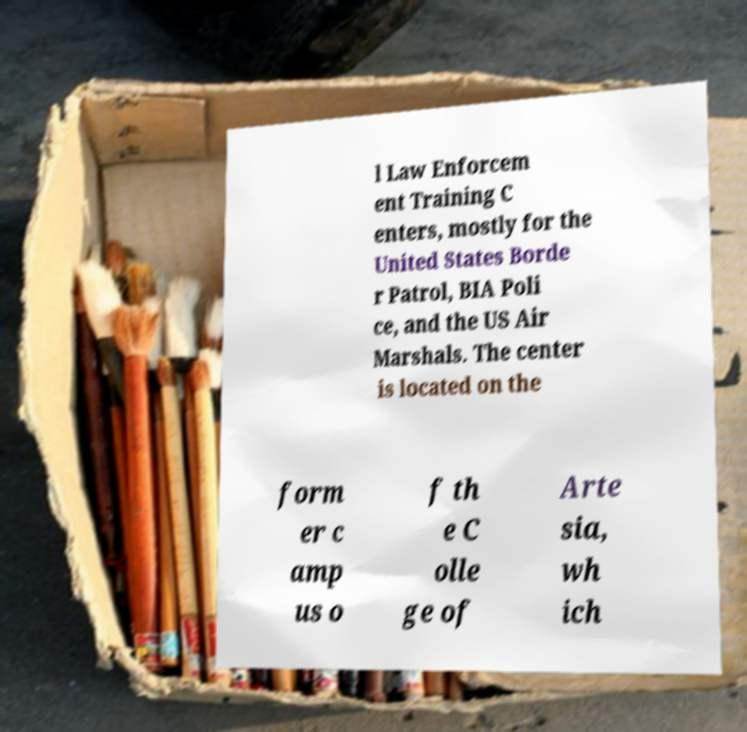Can you accurately transcribe the text from the provided image for me? l Law Enforcem ent Training C enters, mostly for the United States Borde r Patrol, BIA Poli ce, and the US Air Marshals. The center is located on the form er c amp us o f th e C olle ge of Arte sia, wh ich 